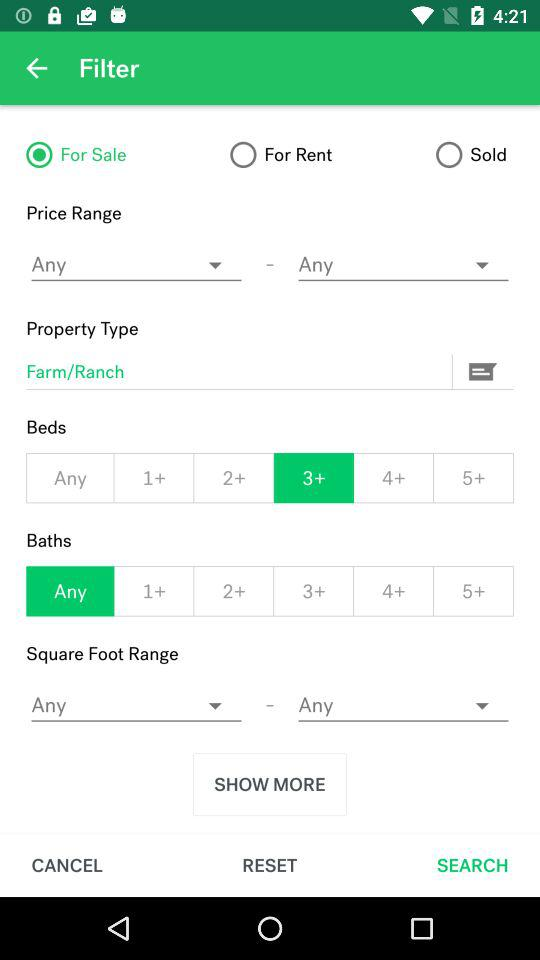How many beds are selected? There are more than 3 selected beds. 